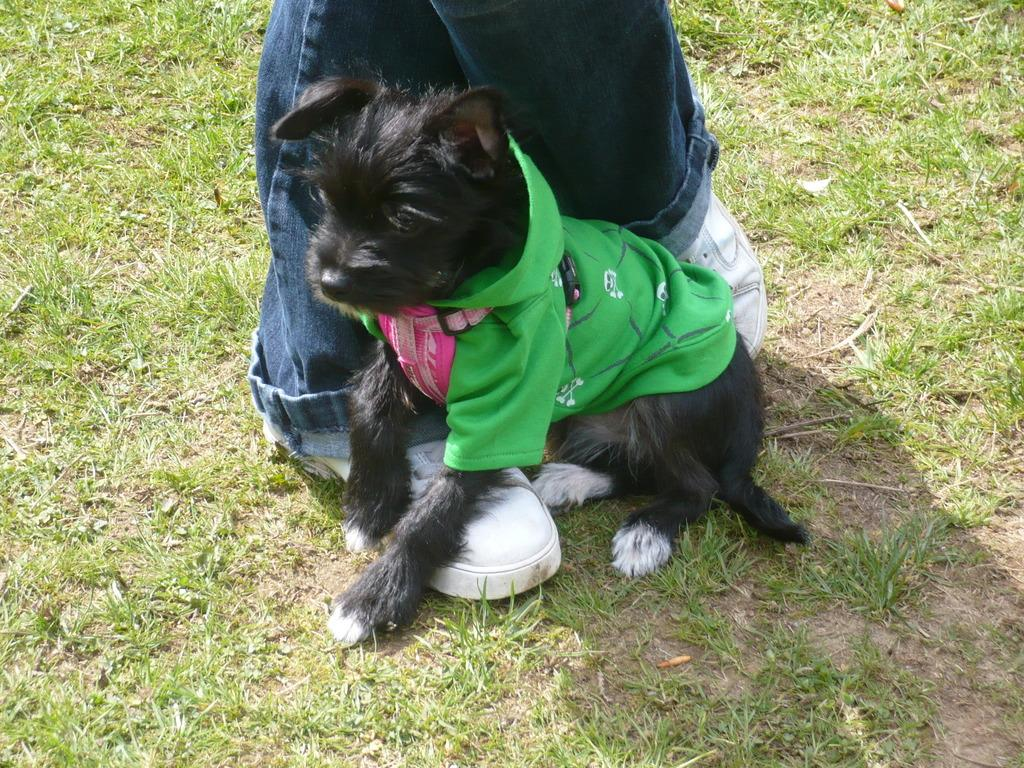What part of a person can be seen in the image? There are legs of a person in the image. What type of terrain is visible in the image? There is grassy land in the image. What animal is present in the image? There is a dog in the image. What is the dog wearing? The dog is wearing a cloth. What type of music is the person playing in the image? There is no indication of music or a person playing music in the image. What achievements has the dog accomplished, as seen in the image? The image does not provide information about the dog's achievements. 